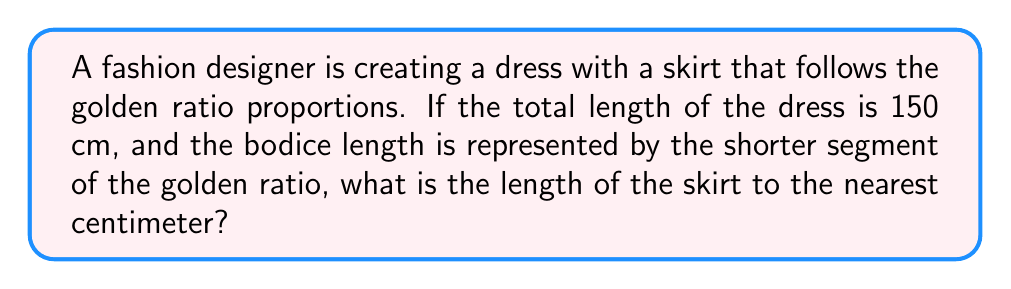Solve this math problem. To solve this problem, we'll use the properties of the golden ratio and apply them to the dress design:

1. The golden ratio, denoted by φ (phi), is approximately equal to 1.618034...

2. In a golden ratio proportion, the ratio of the longer segment to the shorter segment is equal to φ.

3. Let x be the length of the shorter segment (bodice) and y be the length of the longer segment (skirt).

4. We know that x + y = 150 cm (total dress length)

5. The golden ratio states that: 
   $$ \frac{y}{x} = φ $$

6. We can express y in terms of x:
   $$ y = φx $$

7. Substituting this into our total length equation:
   $$ x + φx = 150 $$
   $$ x(1 + φ) = 150 $$

8. Solving for x:
   $$ x = \frac{150}{1 + φ} $$
   $$ x = \frac{150}{1 + 1.618034...} = 57.28 \text{ cm} $$

9. Now we can find y (skirt length):
   $$ y = 150 - x = 150 - 57.28 = 92.72 \text{ cm} $$

10. Rounding to the nearest centimeter:
    $$ y ≈ 93 \text{ cm} $$
Answer: 93 cm 